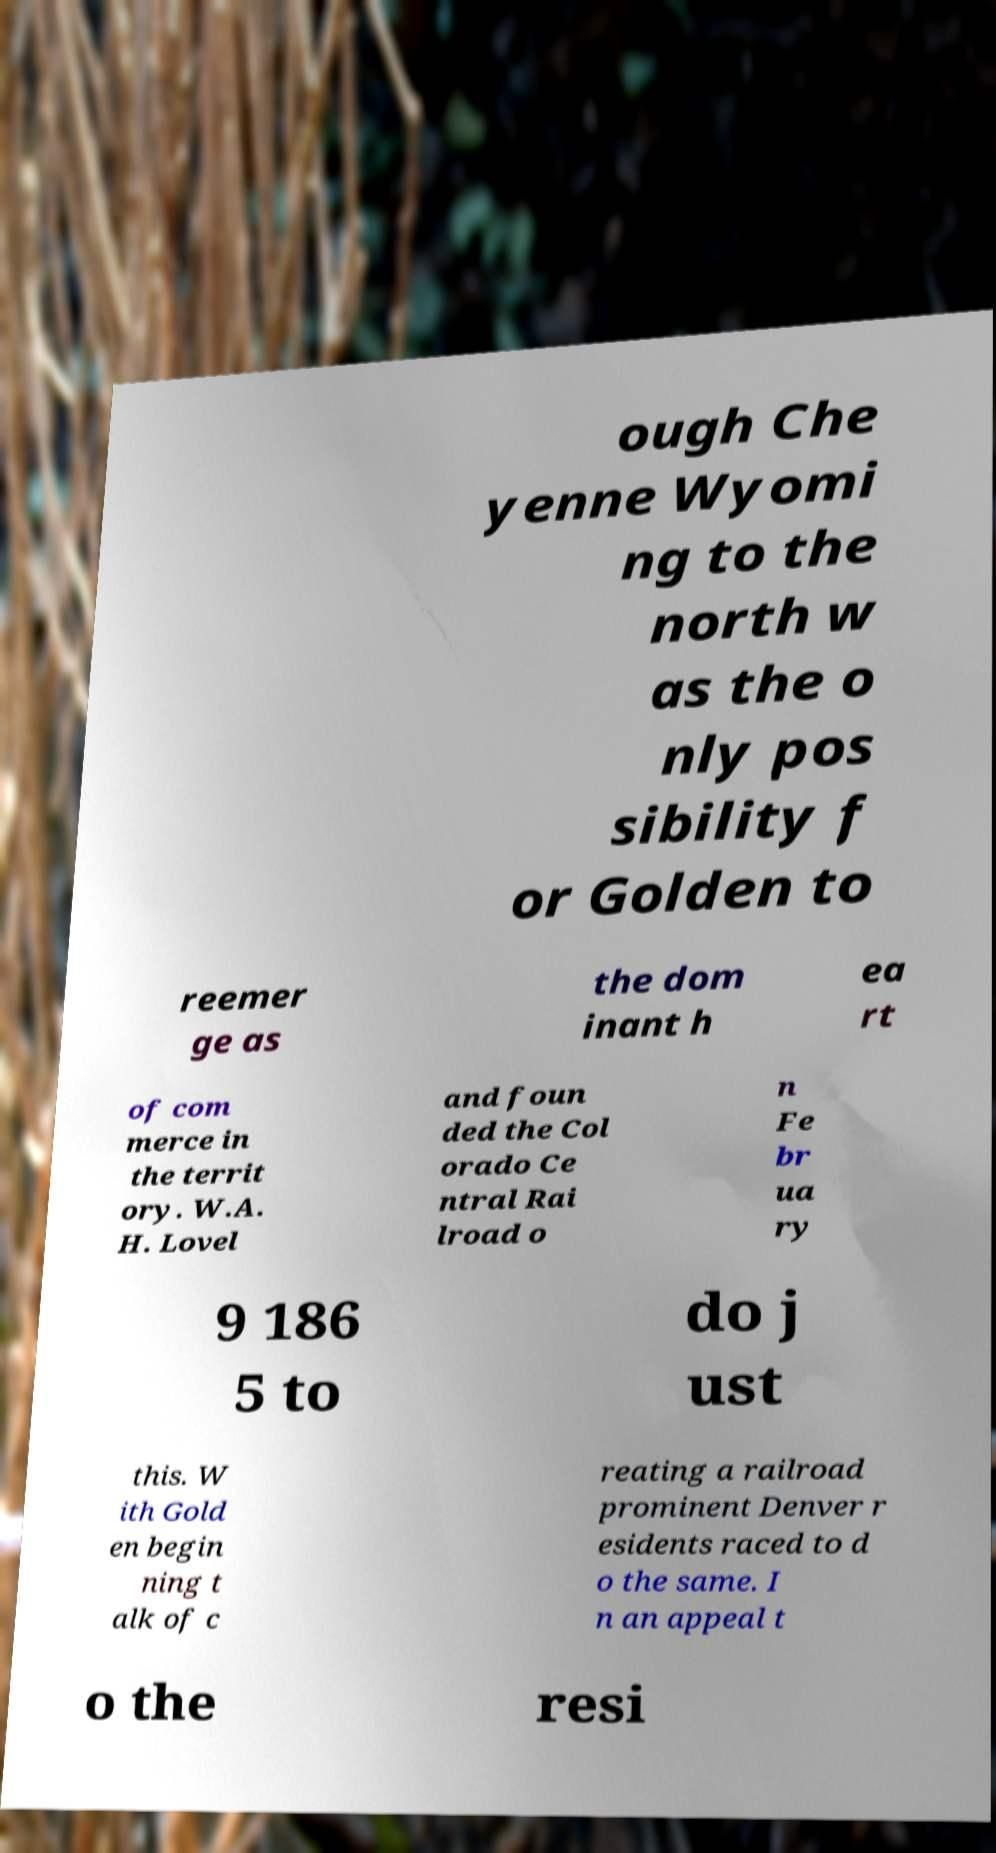Please identify and transcribe the text found in this image. ough Che yenne Wyomi ng to the north w as the o nly pos sibility f or Golden to reemer ge as the dom inant h ea rt of com merce in the territ ory. W.A. H. Lovel and foun ded the Col orado Ce ntral Rai lroad o n Fe br ua ry 9 186 5 to do j ust this. W ith Gold en begin ning t alk of c reating a railroad prominent Denver r esidents raced to d o the same. I n an appeal t o the resi 